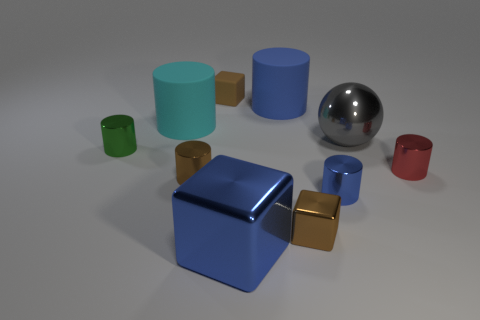The large rubber object that is the same color as the big block is what shape?
Keep it short and to the point. Cylinder. There is a brown block on the right side of the small brown block behind the red metallic thing; what is its material?
Provide a succinct answer. Metal. There is a metallic thing right of the large sphere; is it the same shape as the small brown object that is behind the cyan matte object?
Your response must be concise. No. Are there the same number of gray spheres to the left of the cyan thing and red objects?
Ensure brevity in your answer.  No. There is a blue thing that is behind the big shiny sphere; are there any large blue blocks to the right of it?
Offer a very short reply. No. Are there any other things that are the same color as the large shiny sphere?
Provide a short and direct response. No. Is the material of the blue cylinder that is in front of the large cyan matte thing the same as the gray ball?
Keep it short and to the point. Yes. Are there the same number of green metallic cylinders that are to the right of the brown metal cylinder and gray balls that are behind the big gray ball?
Your answer should be very brief. Yes. There is a brown block that is behind the cyan object behind the small blue metallic object; what size is it?
Keep it short and to the point. Small. What is the cube that is behind the blue shiny block and in front of the green cylinder made of?
Provide a succinct answer. Metal. 